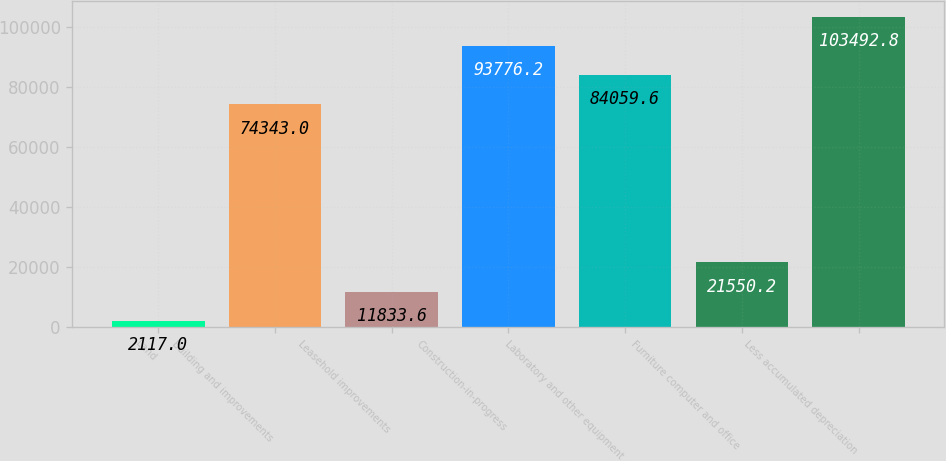Convert chart to OTSL. <chart><loc_0><loc_0><loc_500><loc_500><bar_chart><fcel>Land<fcel>Building and improvements<fcel>Leasehold improvements<fcel>Construction-in-progress<fcel>Laboratory and other equipment<fcel>Furniture computer and office<fcel>Less accumulated depreciation<nl><fcel>2117<fcel>74343<fcel>11833.6<fcel>93776.2<fcel>84059.6<fcel>21550.2<fcel>103493<nl></chart> 